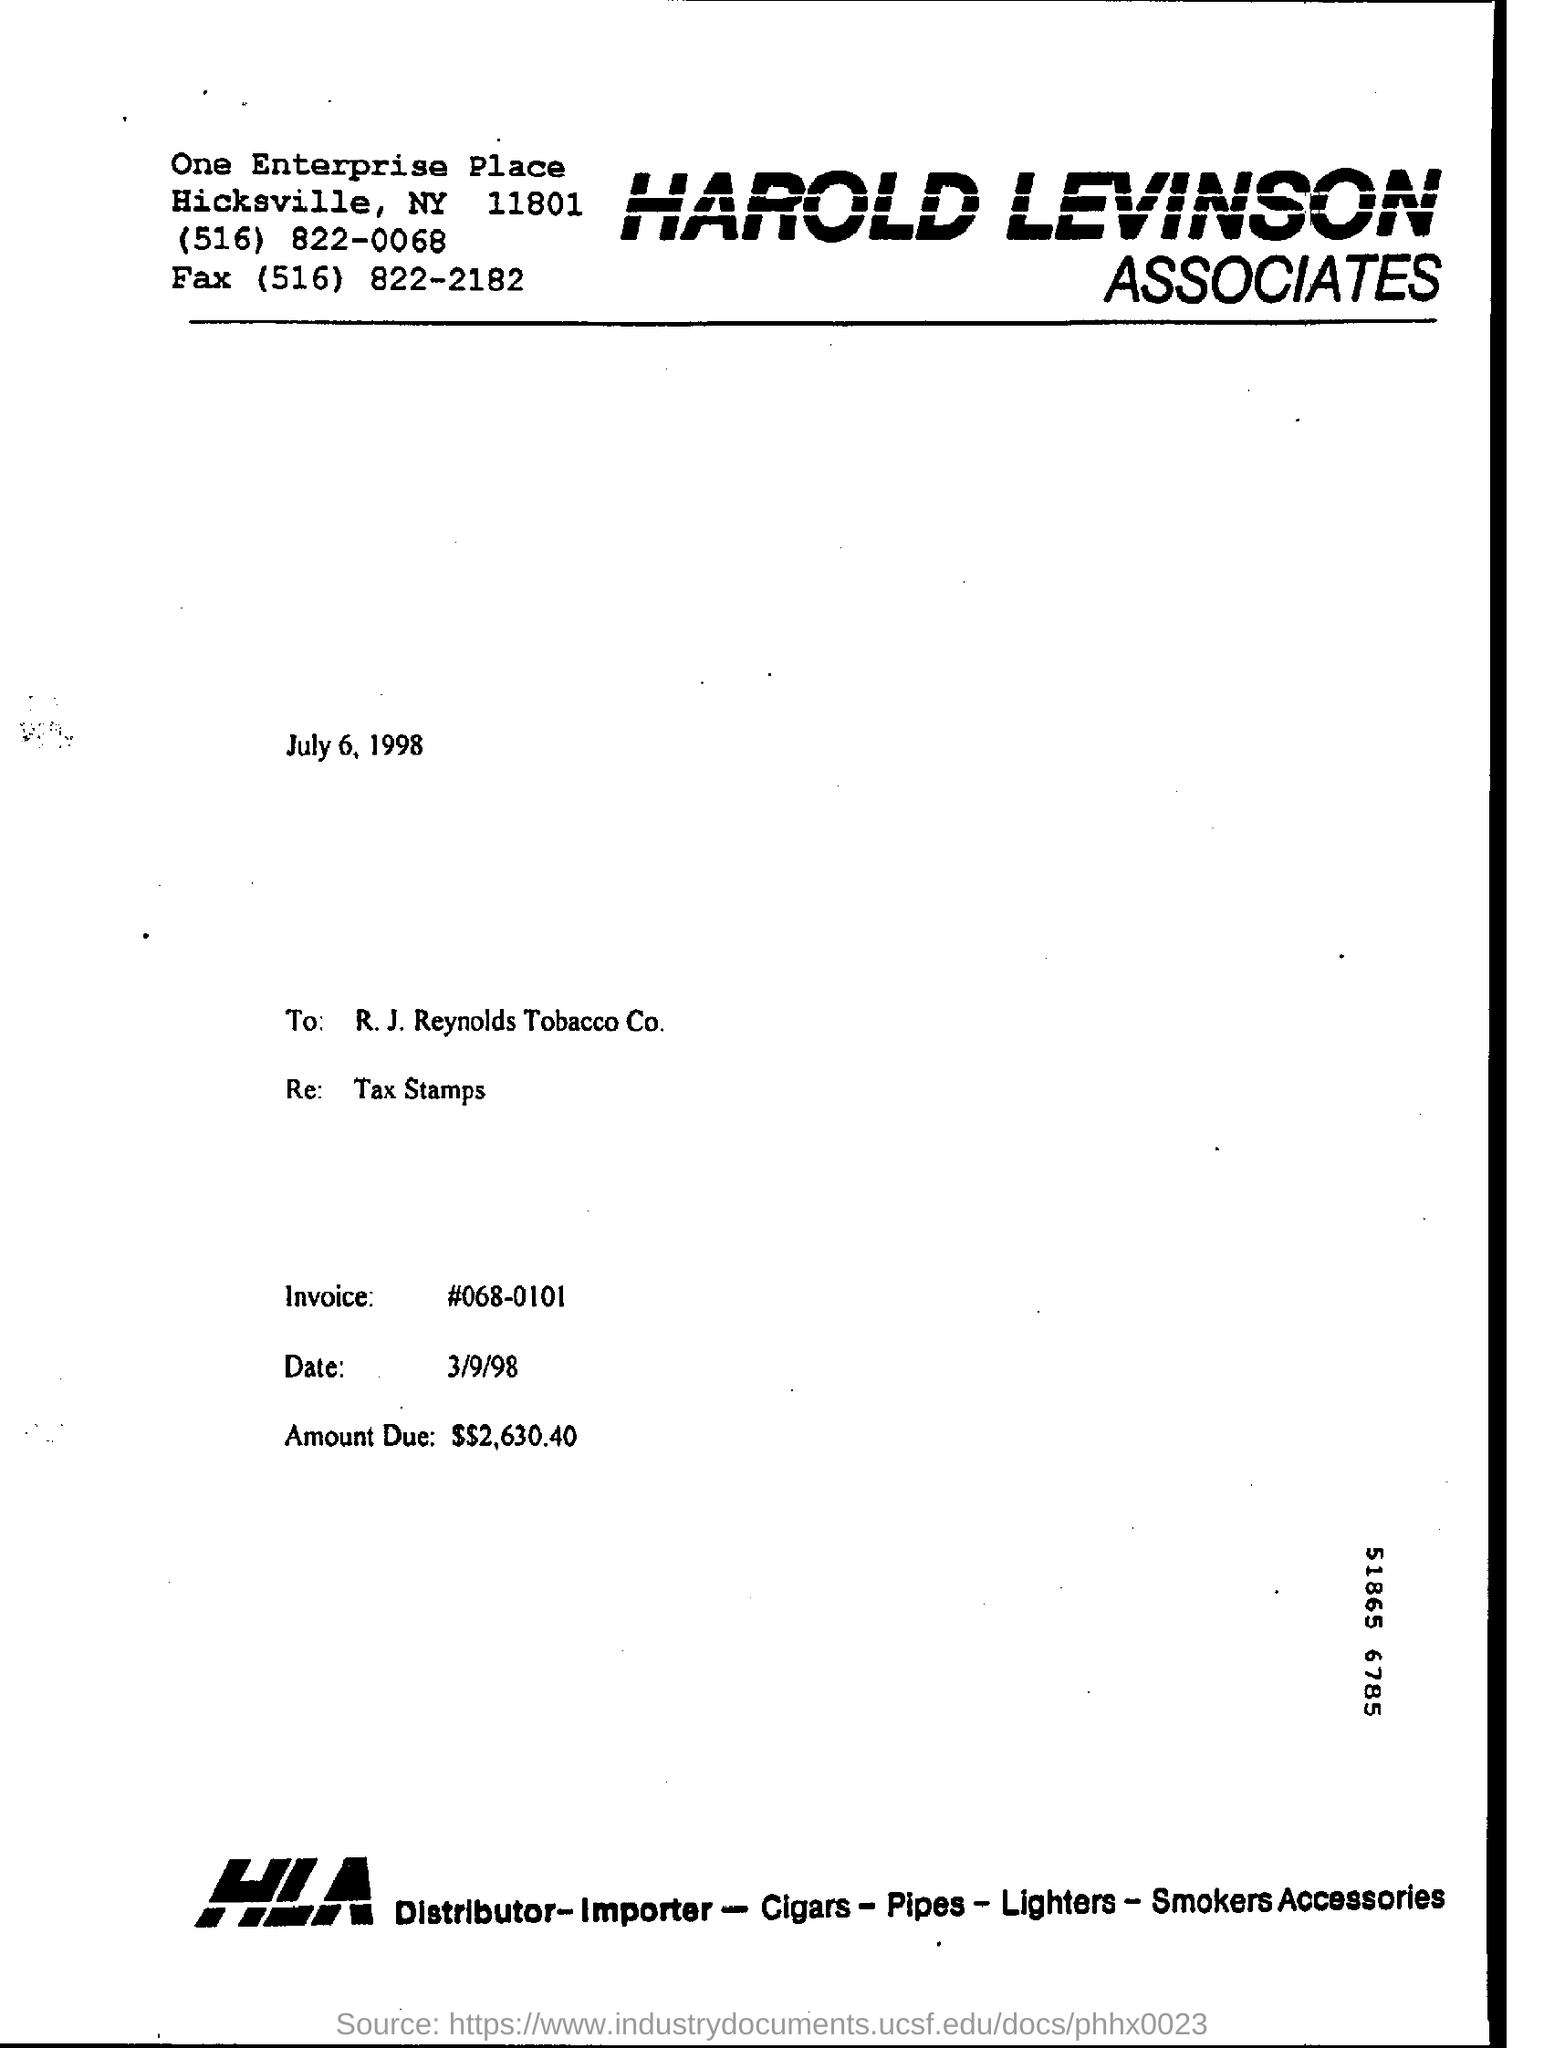What is the Invoice number given in this page
Offer a very short reply. 068-0101. 